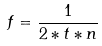<formula> <loc_0><loc_0><loc_500><loc_500>f = \frac { 1 } { 2 * t * n }</formula> 